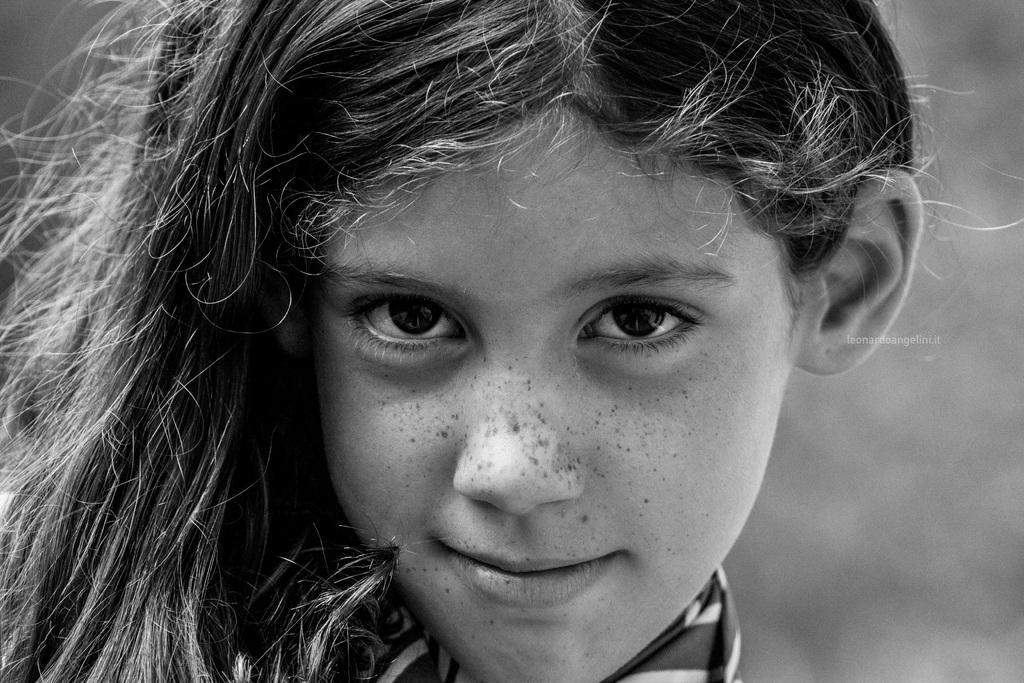Describe this image in one or two sentences. This is a black and white image. In this image we can see a girl. 